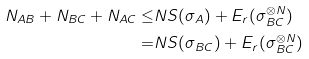Convert formula to latex. <formula><loc_0><loc_0><loc_500><loc_500>N _ { A B } + N _ { B C } + N _ { A C } \leq & N S ( \sigma _ { A } ) + E _ { r } ( \sigma _ { B C } ^ { \otimes N } ) \\ = & N S ( \sigma _ { B C } ) + E _ { r } ( \sigma _ { B C } ^ { \otimes N } )</formula> 